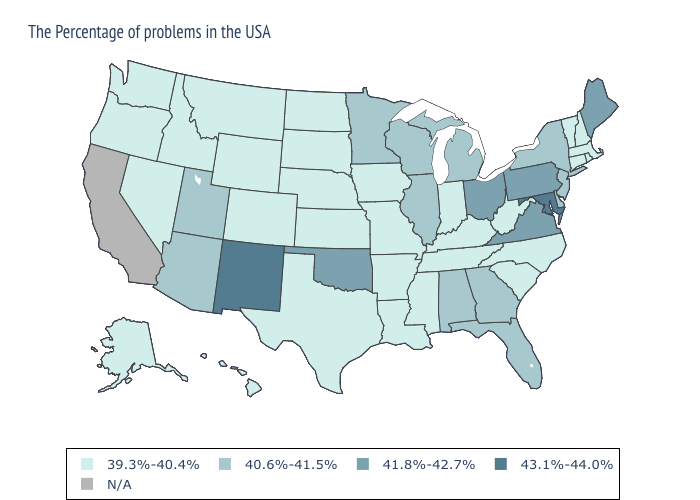Does the map have missing data?
Give a very brief answer. Yes. Name the states that have a value in the range 40.6%-41.5%?
Concise answer only. New York, New Jersey, Delaware, Florida, Georgia, Michigan, Alabama, Wisconsin, Illinois, Minnesota, Utah, Arizona. Among the states that border New Jersey , which have the highest value?
Quick response, please. Pennsylvania. Which states hav the highest value in the South?
Concise answer only. Maryland. What is the highest value in the Northeast ?
Write a very short answer. 41.8%-42.7%. Does Oregon have the lowest value in the West?
Answer briefly. Yes. Does West Virginia have the highest value in the South?
Quick response, please. No. What is the value of Utah?
Write a very short answer. 40.6%-41.5%. Does Georgia have the lowest value in the South?
Be succinct. No. Name the states that have a value in the range 40.6%-41.5%?
Answer briefly. New York, New Jersey, Delaware, Florida, Georgia, Michigan, Alabama, Wisconsin, Illinois, Minnesota, Utah, Arizona. What is the highest value in the USA?
Keep it brief. 43.1%-44.0%. What is the highest value in states that border California?
Concise answer only. 40.6%-41.5%. What is the lowest value in the Northeast?
Short answer required. 39.3%-40.4%. What is the value of Tennessee?
Be succinct. 39.3%-40.4%. Among the states that border New Mexico , does Utah have the lowest value?
Quick response, please. No. 